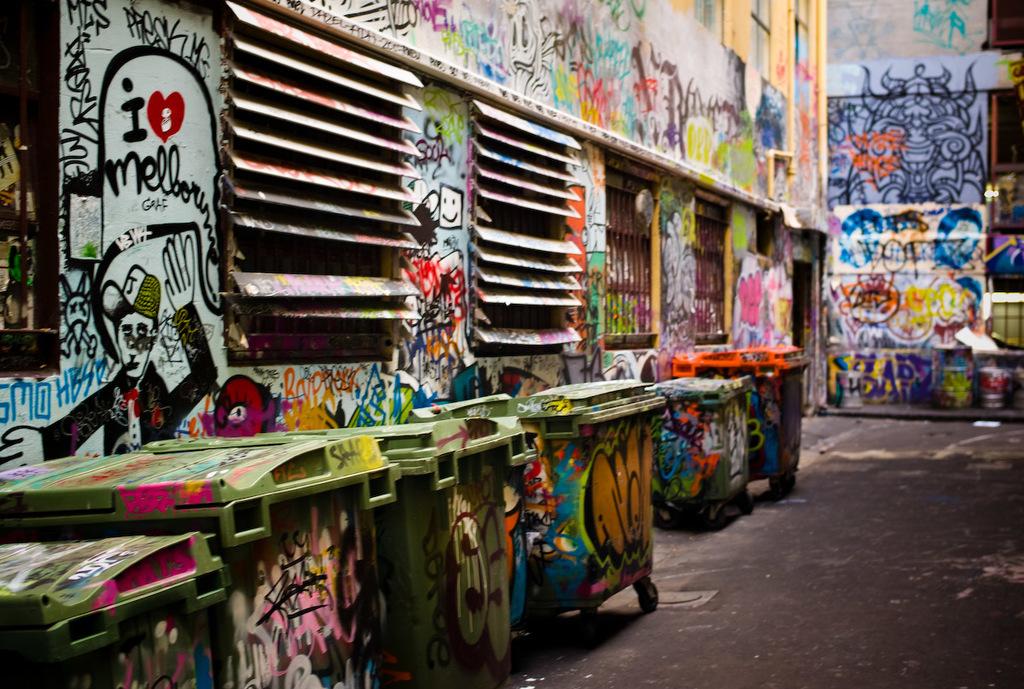The graffiti mentions that someone loves what location?
Your answer should be very brief. Melbourne. Who loves the city of melbourne?
Provide a short and direct response. I. 